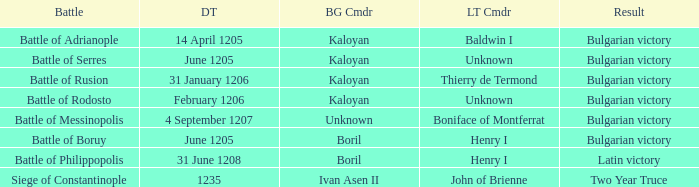On what Date was Henry I Latin Commander of the Battle of Boruy? June 1205. 